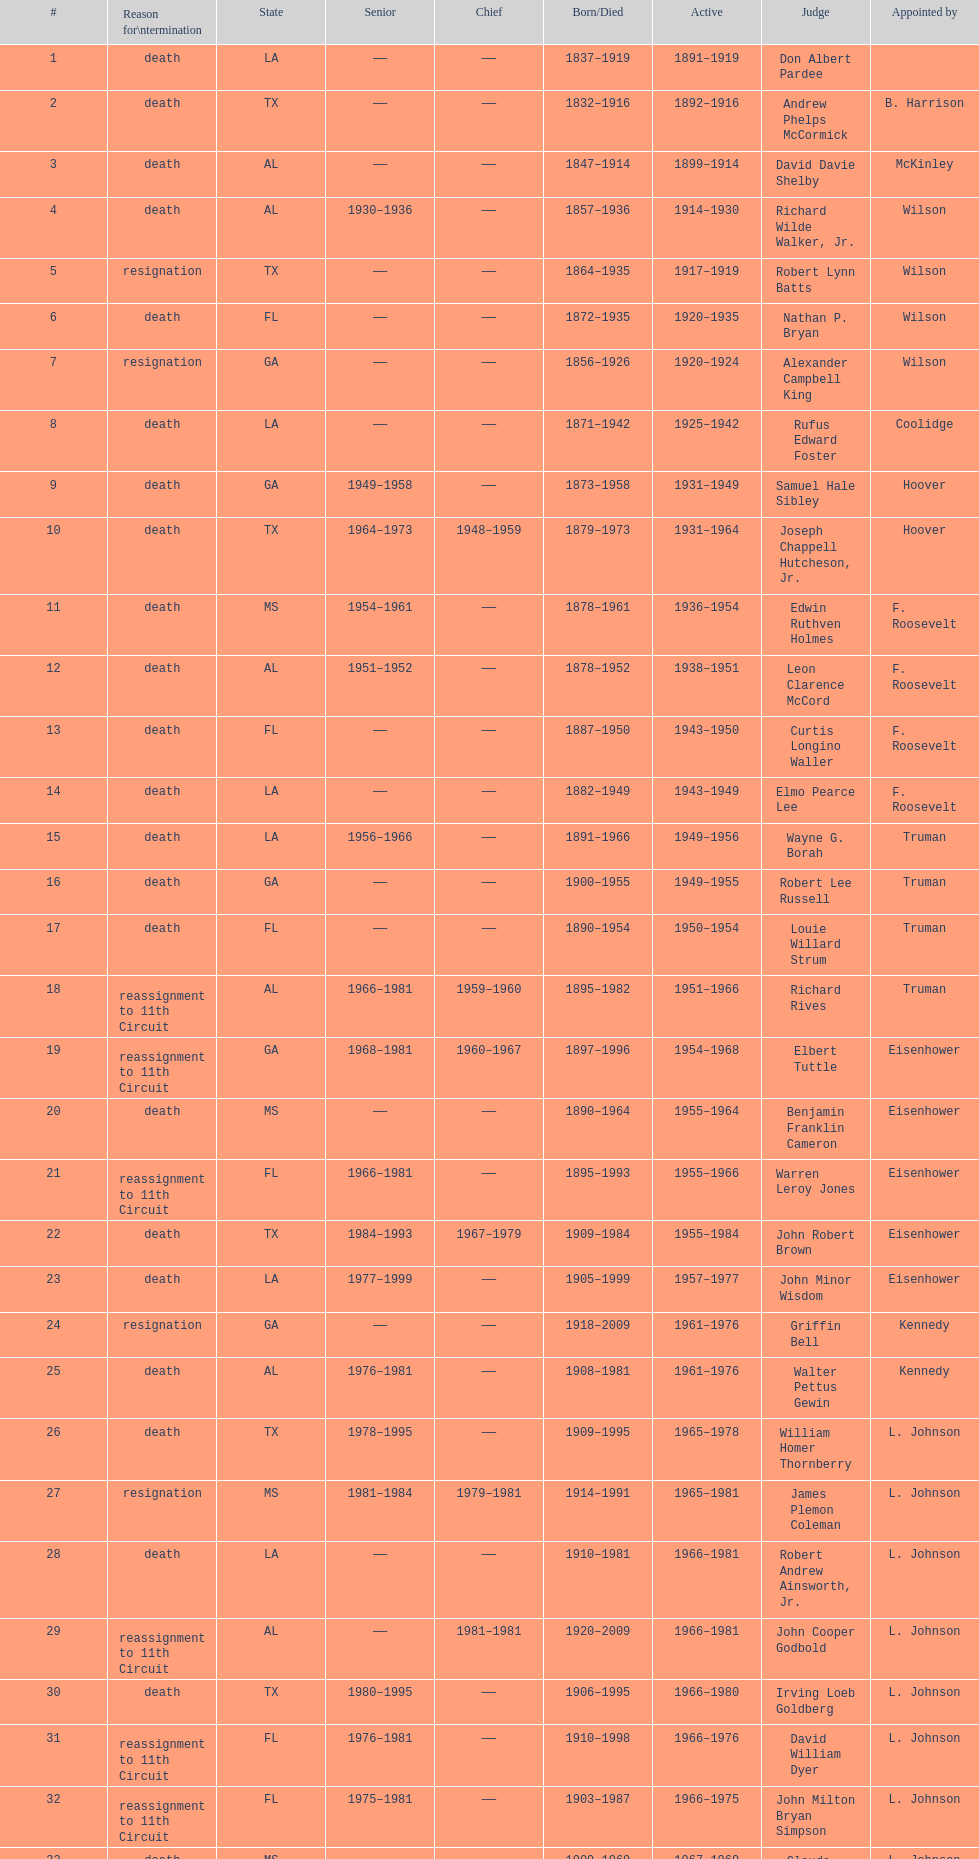Who was the first judge appointed from georgia? Alexander Campbell King. 